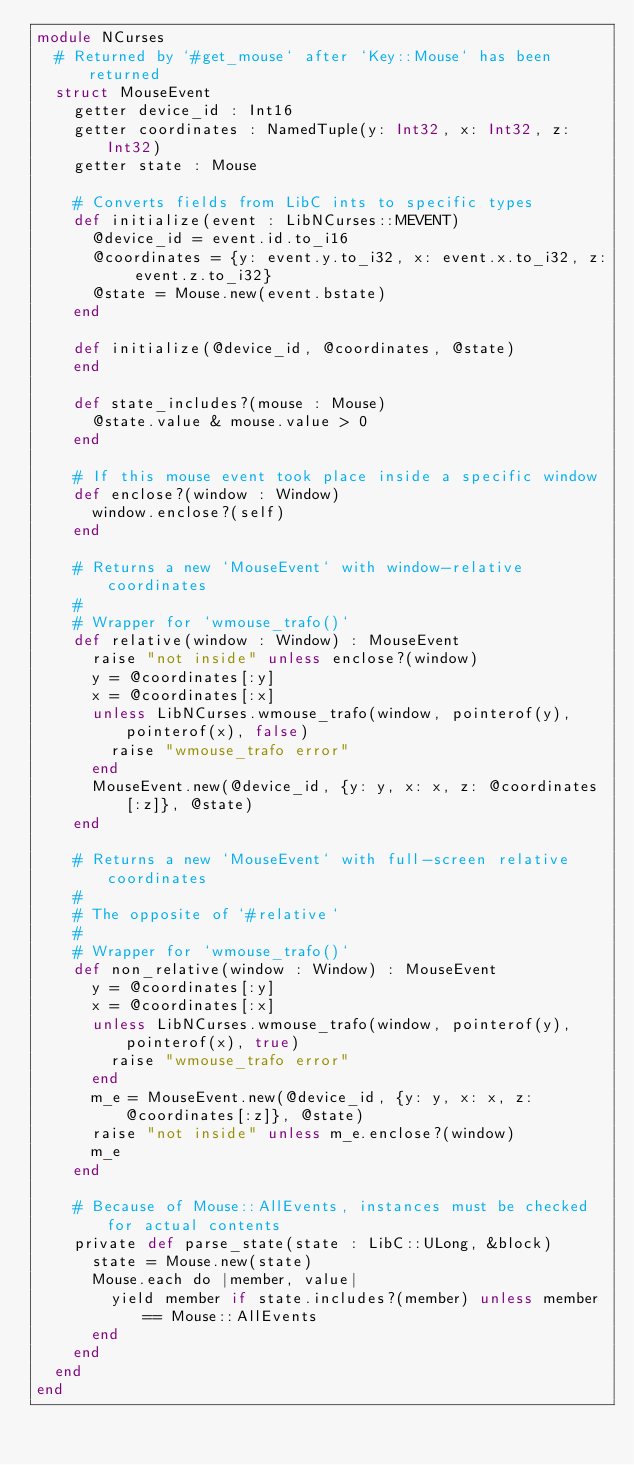<code> <loc_0><loc_0><loc_500><loc_500><_Crystal_>module NCurses
  # Returned by `#get_mouse` after `Key::Mouse` has been returned
  struct MouseEvent
    getter device_id : Int16
    getter coordinates : NamedTuple(y: Int32, x: Int32, z: Int32)
    getter state : Mouse

    # Converts fields from LibC ints to specific types
    def initialize(event : LibNCurses::MEVENT)
      @device_id = event.id.to_i16
      @coordinates = {y: event.y.to_i32, x: event.x.to_i32, z: event.z.to_i32}
      @state = Mouse.new(event.bstate)
    end

    def initialize(@device_id, @coordinates, @state)
    end

    def state_includes?(mouse : Mouse)
      @state.value & mouse.value > 0
    end

    # If this mouse event took place inside a specific window
    def enclose?(window : Window)
      window.enclose?(self)
    end

    # Returns a new `MouseEvent` with window-relative coordinates
    #
    # Wrapper for `wmouse_trafo()`
    def relative(window : Window) : MouseEvent
      raise "not inside" unless enclose?(window)
      y = @coordinates[:y]
      x = @coordinates[:x]
      unless LibNCurses.wmouse_trafo(window, pointerof(y), pointerof(x), false)
        raise "wmouse_trafo error"
      end
      MouseEvent.new(@device_id, {y: y, x: x, z: @coordinates[:z]}, @state)
    end

    # Returns a new `MouseEvent` with full-screen relative coordinates
    #
    # The opposite of `#relative`
    #
    # Wrapper for `wmouse_trafo()`
    def non_relative(window : Window) : MouseEvent
      y = @coordinates[:y]
      x = @coordinates[:x]
      unless LibNCurses.wmouse_trafo(window, pointerof(y), pointerof(x), true)
        raise "wmouse_trafo error"
      end
      m_e = MouseEvent.new(@device_id, {y: y, x: x, z: @coordinates[:z]}, @state)
      raise "not inside" unless m_e.enclose?(window)
      m_e
    end

    # Because of Mouse::AllEvents, instances must be checked for actual contents
    private def parse_state(state : LibC::ULong, &block)
      state = Mouse.new(state)
      Mouse.each do |member, value|
        yield member if state.includes?(member) unless member == Mouse::AllEvents
      end
    end
  end
end
</code> 